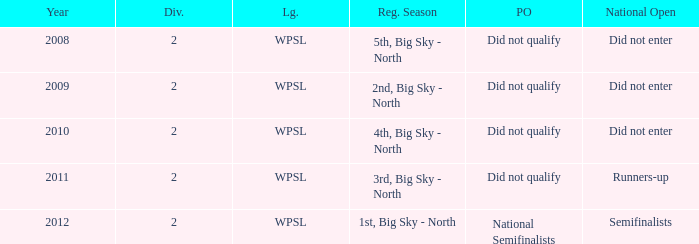What is the lowest division number? 2.0. 